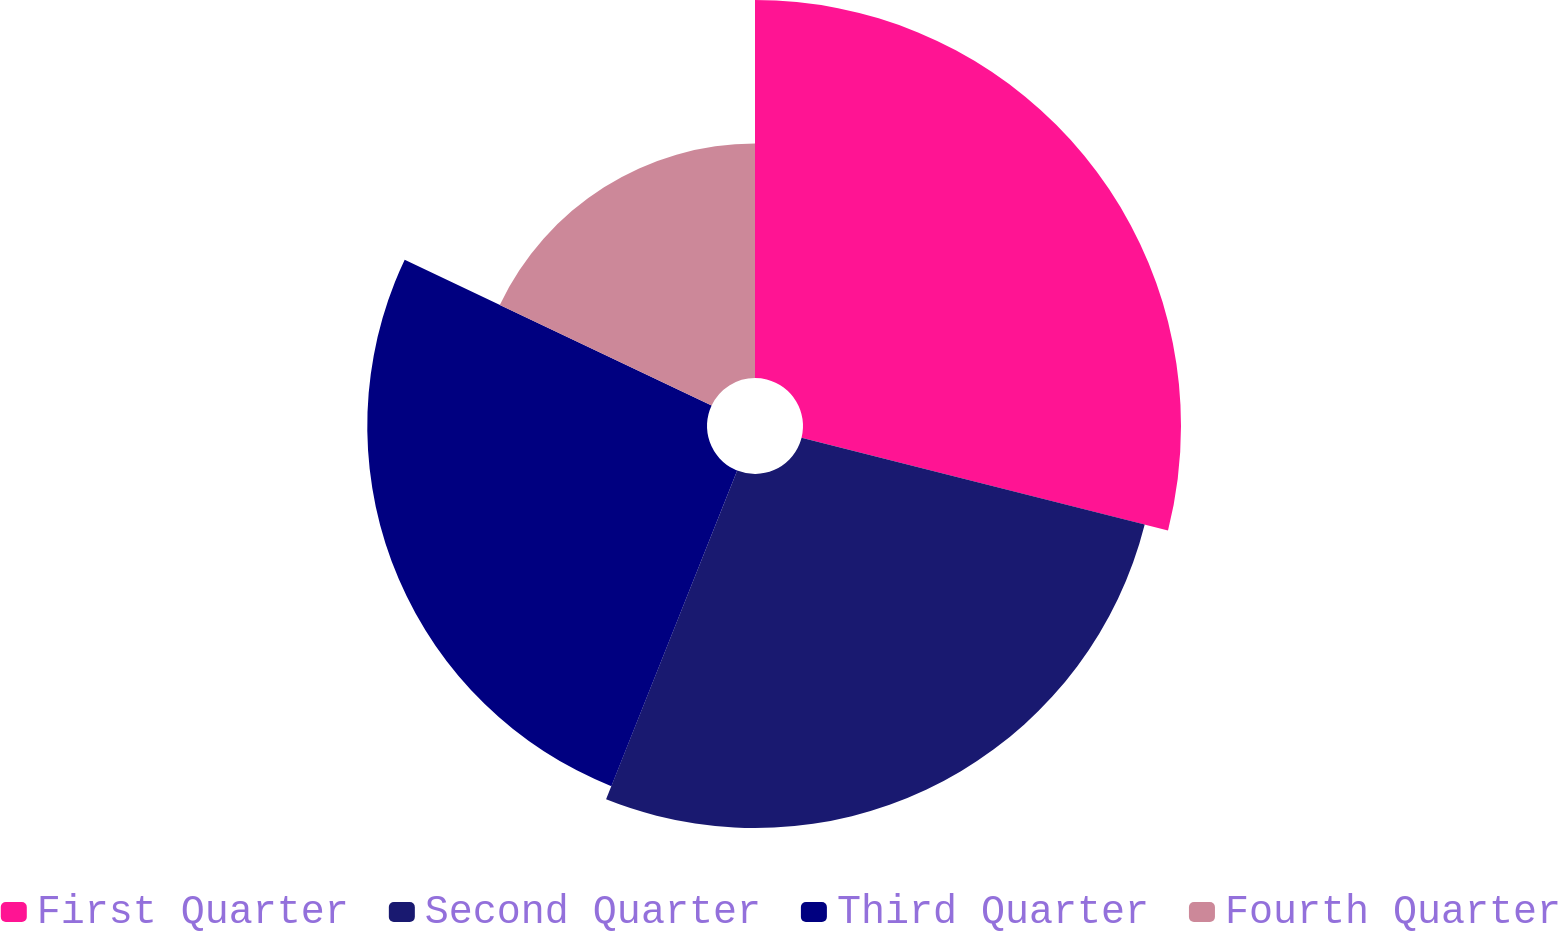Convert chart to OTSL. <chart><loc_0><loc_0><loc_500><loc_500><pie_chart><fcel>First Quarter<fcel>Second Quarter<fcel>Third Quarter<fcel>Fourth Quarter<nl><fcel>28.94%<fcel>27.1%<fcel>26.01%<fcel>17.95%<nl></chart> 